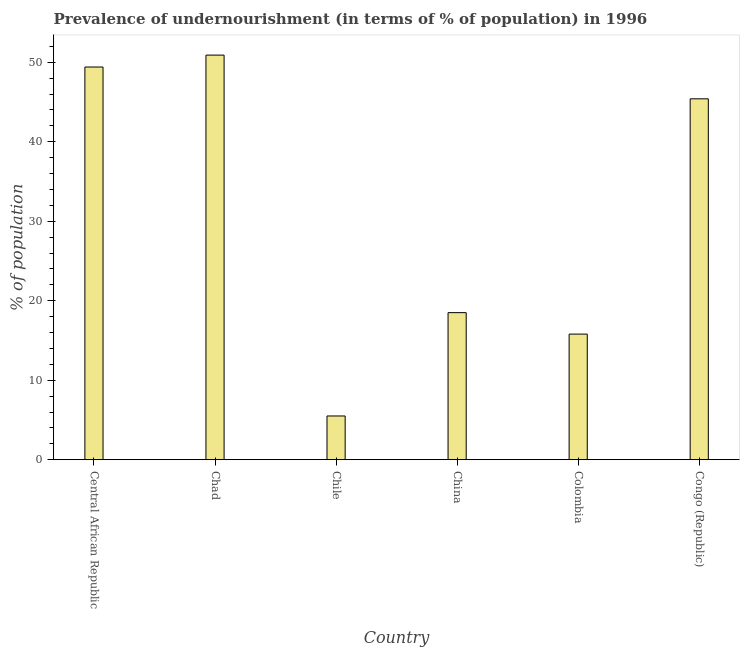Does the graph contain grids?
Ensure brevity in your answer.  No. What is the title of the graph?
Make the answer very short. Prevalence of undernourishment (in terms of % of population) in 1996. What is the label or title of the X-axis?
Offer a very short reply. Country. What is the label or title of the Y-axis?
Make the answer very short. % of population. What is the percentage of undernourished population in Central African Republic?
Offer a very short reply. 49.4. Across all countries, what is the maximum percentage of undernourished population?
Provide a succinct answer. 50.9. Across all countries, what is the minimum percentage of undernourished population?
Your answer should be compact. 5.5. In which country was the percentage of undernourished population maximum?
Your answer should be compact. Chad. What is the sum of the percentage of undernourished population?
Offer a terse response. 185.5. What is the difference between the percentage of undernourished population in Chad and Colombia?
Make the answer very short. 35.1. What is the average percentage of undernourished population per country?
Provide a succinct answer. 30.92. What is the median percentage of undernourished population?
Your answer should be very brief. 31.95. What is the ratio of the percentage of undernourished population in China to that in Colombia?
Make the answer very short. 1.17. Is the difference between the percentage of undernourished population in Central African Republic and Chile greater than the difference between any two countries?
Offer a terse response. No. What is the difference between the highest and the second highest percentage of undernourished population?
Your answer should be compact. 1.5. Is the sum of the percentage of undernourished population in Chad and Colombia greater than the maximum percentage of undernourished population across all countries?
Ensure brevity in your answer.  Yes. What is the difference between the highest and the lowest percentage of undernourished population?
Your answer should be very brief. 45.4. Are all the bars in the graph horizontal?
Give a very brief answer. No. What is the difference between two consecutive major ticks on the Y-axis?
Keep it short and to the point. 10. What is the % of population in Central African Republic?
Your answer should be very brief. 49.4. What is the % of population in Chad?
Give a very brief answer. 50.9. What is the % of population of Chile?
Ensure brevity in your answer.  5.5. What is the % of population in Congo (Republic)?
Keep it short and to the point. 45.4. What is the difference between the % of population in Central African Republic and Chile?
Give a very brief answer. 43.9. What is the difference between the % of population in Central African Republic and China?
Keep it short and to the point. 30.9. What is the difference between the % of population in Central African Republic and Colombia?
Make the answer very short. 33.6. What is the difference between the % of population in Chad and Chile?
Offer a very short reply. 45.4. What is the difference between the % of population in Chad and China?
Give a very brief answer. 32.4. What is the difference between the % of population in Chad and Colombia?
Keep it short and to the point. 35.1. What is the difference between the % of population in Chad and Congo (Republic)?
Offer a terse response. 5.5. What is the difference between the % of population in Chile and Congo (Republic)?
Your answer should be very brief. -39.9. What is the difference between the % of population in China and Congo (Republic)?
Offer a terse response. -26.9. What is the difference between the % of population in Colombia and Congo (Republic)?
Your answer should be very brief. -29.6. What is the ratio of the % of population in Central African Republic to that in Chile?
Keep it short and to the point. 8.98. What is the ratio of the % of population in Central African Republic to that in China?
Your response must be concise. 2.67. What is the ratio of the % of population in Central African Republic to that in Colombia?
Your answer should be very brief. 3.13. What is the ratio of the % of population in Central African Republic to that in Congo (Republic)?
Your answer should be very brief. 1.09. What is the ratio of the % of population in Chad to that in Chile?
Provide a short and direct response. 9.26. What is the ratio of the % of population in Chad to that in China?
Your response must be concise. 2.75. What is the ratio of the % of population in Chad to that in Colombia?
Give a very brief answer. 3.22. What is the ratio of the % of population in Chad to that in Congo (Republic)?
Provide a succinct answer. 1.12. What is the ratio of the % of population in Chile to that in China?
Your answer should be very brief. 0.3. What is the ratio of the % of population in Chile to that in Colombia?
Make the answer very short. 0.35. What is the ratio of the % of population in Chile to that in Congo (Republic)?
Provide a short and direct response. 0.12. What is the ratio of the % of population in China to that in Colombia?
Your answer should be very brief. 1.17. What is the ratio of the % of population in China to that in Congo (Republic)?
Your answer should be very brief. 0.41. What is the ratio of the % of population in Colombia to that in Congo (Republic)?
Ensure brevity in your answer.  0.35. 